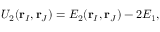<formula> <loc_0><loc_0><loc_500><loc_500>U _ { 2 } ( r _ { I } , r _ { J } ) = E _ { 2 } ( r _ { I } , r _ { J } ) - 2 E _ { 1 } ,</formula> 